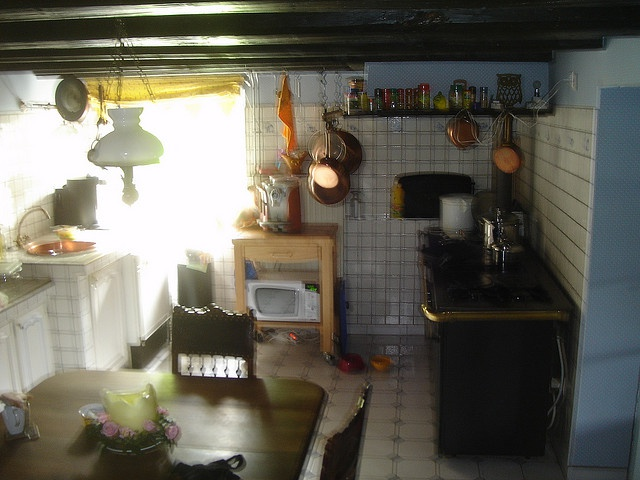Describe the objects in this image and their specific colors. I can see oven in black and gray tones, dining table in black, gray, darkgreen, and darkgray tones, chair in black, lightgray, and darkgray tones, potted plant in black, olive, gray, and darkgreen tones, and microwave in black and gray tones in this image. 